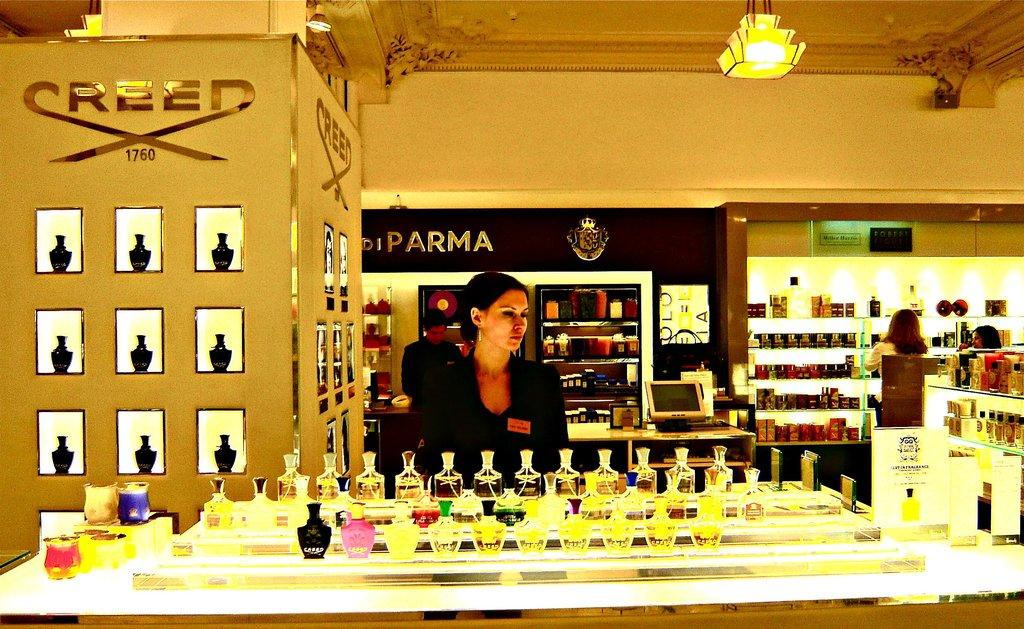<image>
Give a short and clear explanation of the subsequent image. A woman stands before a fragrance counter at a store; in the background is a display bearing a logo for Red cosmetics. 